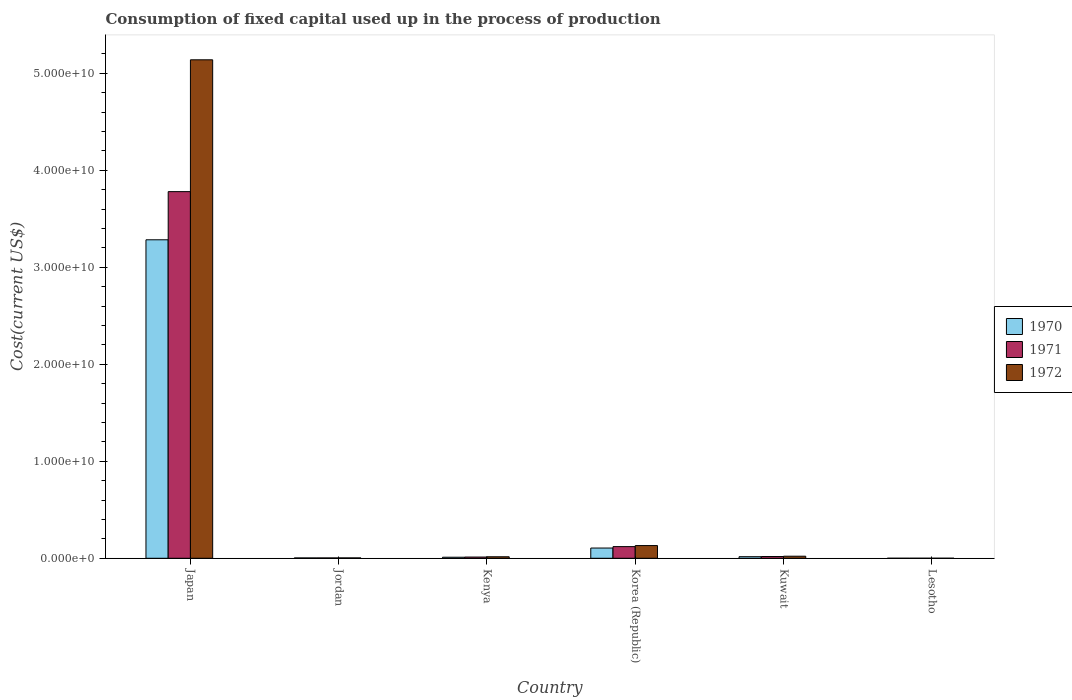How many different coloured bars are there?
Offer a very short reply. 3. Are the number of bars per tick equal to the number of legend labels?
Make the answer very short. Yes. In how many cases, is the number of bars for a given country not equal to the number of legend labels?
Your answer should be compact. 0. What is the amount consumed in the process of production in 1970 in Lesotho?
Ensure brevity in your answer.  1.88e+06. Across all countries, what is the maximum amount consumed in the process of production in 1972?
Offer a terse response. 5.14e+1. Across all countries, what is the minimum amount consumed in the process of production in 1970?
Provide a succinct answer. 1.88e+06. In which country was the amount consumed in the process of production in 1971 minimum?
Provide a succinct answer. Lesotho. What is the total amount consumed in the process of production in 1971 in the graph?
Offer a terse response. 3.93e+1. What is the difference between the amount consumed in the process of production in 1972 in Jordan and that in Lesotho?
Ensure brevity in your answer.  3.64e+07. What is the difference between the amount consumed in the process of production in 1971 in Kenya and the amount consumed in the process of production in 1970 in Japan?
Your answer should be compact. -3.27e+1. What is the average amount consumed in the process of production in 1971 per country?
Keep it short and to the point. 6.56e+09. What is the difference between the amount consumed in the process of production of/in 1972 and amount consumed in the process of production of/in 1970 in Korea (Republic)?
Provide a short and direct response. 2.55e+08. What is the ratio of the amount consumed in the process of production in 1972 in Kenya to that in Lesotho?
Offer a terse response. 70.16. Is the difference between the amount consumed in the process of production in 1972 in Jordan and Lesotho greater than the difference between the amount consumed in the process of production in 1970 in Jordan and Lesotho?
Your response must be concise. Yes. What is the difference between the highest and the second highest amount consumed in the process of production in 1970?
Give a very brief answer. -3.18e+1. What is the difference between the highest and the lowest amount consumed in the process of production in 1970?
Offer a very short reply. 3.28e+1. In how many countries, is the amount consumed in the process of production in 1971 greater than the average amount consumed in the process of production in 1971 taken over all countries?
Your response must be concise. 1. What does the 3rd bar from the left in Kuwait represents?
Offer a very short reply. 1972. Is it the case that in every country, the sum of the amount consumed in the process of production in 1972 and amount consumed in the process of production in 1971 is greater than the amount consumed in the process of production in 1970?
Make the answer very short. Yes. How many bars are there?
Your answer should be very brief. 18. Are all the bars in the graph horizontal?
Offer a very short reply. No. What is the difference between two consecutive major ticks on the Y-axis?
Offer a terse response. 1.00e+1. Does the graph contain any zero values?
Provide a succinct answer. No. Does the graph contain grids?
Give a very brief answer. No. How many legend labels are there?
Your answer should be very brief. 3. What is the title of the graph?
Your answer should be compact. Consumption of fixed capital used up in the process of production. Does "2001" appear as one of the legend labels in the graph?
Keep it short and to the point. No. What is the label or title of the X-axis?
Provide a succinct answer. Country. What is the label or title of the Y-axis?
Offer a terse response. Cost(current US$). What is the Cost(current US$) of 1970 in Japan?
Provide a short and direct response. 3.28e+1. What is the Cost(current US$) in 1971 in Japan?
Offer a terse response. 3.78e+1. What is the Cost(current US$) of 1972 in Japan?
Provide a short and direct response. 5.14e+1. What is the Cost(current US$) of 1970 in Jordan?
Offer a terse response. 3.46e+07. What is the Cost(current US$) of 1971 in Jordan?
Make the answer very short. 3.55e+07. What is the Cost(current US$) in 1972 in Jordan?
Offer a terse response. 3.86e+07. What is the Cost(current US$) of 1970 in Kenya?
Make the answer very short. 1.08e+08. What is the Cost(current US$) in 1971 in Kenya?
Give a very brief answer. 1.25e+08. What is the Cost(current US$) of 1972 in Kenya?
Offer a very short reply. 1.55e+08. What is the Cost(current US$) of 1970 in Korea (Republic)?
Keep it short and to the point. 1.05e+09. What is the Cost(current US$) of 1971 in Korea (Republic)?
Give a very brief answer. 1.20e+09. What is the Cost(current US$) of 1972 in Korea (Republic)?
Offer a terse response. 1.31e+09. What is the Cost(current US$) of 1970 in Kuwait?
Keep it short and to the point. 1.62e+08. What is the Cost(current US$) in 1971 in Kuwait?
Your answer should be compact. 1.80e+08. What is the Cost(current US$) of 1972 in Kuwait?
Offer a terse response. 2.13e+08. What is the Cost(current US$) of 1970 in Lesotho?
Provide a succinct answer. 1.88e+06. What is the Cost(current US$) of 1971 in Lesotho?
Ensure brevity in your answer.  2.43e+06. What is the Cost(current US$) in 1972 in Lesotho?
Ensure brevity in your answer.  2.21e+06. Across all countries, what is the maximum Cost(current US$) in 1970?
Your answer should be compact. 3.28e+1. Across all countries, what is the maximum Cost(current US$) in 1971?
Ensure brevity in your answer.  3.78e+1. Across all countries, what is the maximum Cost(current US$) in 1972?
Your response must be concise. 5.14e+1. Across all countries, what is the minimum Cost(current US$) in 1970?
Your answer should be very brief. 1.88e+06. Across all countries, what is the minimum Cost(current US$) in 1971?
Your response must be concise. 2.43e+06. Across all countries, what is the minimum Cost(current US$) of 1972?
Your response must be concise. 2.21e+06. What is the total Cost(current US$) of 1970 in the graph?
Make the answer very short. 3.42e+1. What is the total Cost(current US$) in 1971 in the graph?
Offer a very short reply. 3.93e+1. What is the total Cost(current US$) of 1972 in the graph?
Offer a very short reply. 5.31e+1. What is the difference between the Cost(current US$) of 1970 in Japan and that in Jordan?
Your answer should be very brief. 3.28e+1. What is the difference between the Cost(current US$) in 1971 in Japan and that in Jordan?
Offer a terse response. 3.78e+1. What is the difference between the Cost(current US$) in 1972 in Japan and that in Jordan?
Provide a short and direct response. 5.14e+1. What is the difference between the Cost(current US$) in 1970 in Japan and that in Kenya?
Ensure brevity in your answer.  3.27e+1. What is the difference between the Cost(current US$) in 1971 in Japan and that in Kenya?
Give a very brief answer. 3.77e+1. What is the difference between the Cost(current US$) in 1972 in Japan and that in Kenya?
Keep it short and to the point. 5.12e+1. What is the difference between the Cost(current US$) of 1970 in Japan and that in Korea (Republic)?
Keep it short and to the point. 3.18e+1. What is the difference between the Cost(current US$) of 1971 in Japan and that in Korea (Republic)?
Keep it short and to the point. 3.66e+1. What is the difference between the Cost(current US$) of 1972 in Japan and that in Korea (Republic)?
Give a very brief answer. 5.01e+1. What is the difference between the Cost(current US$) of 1970 in Japan and that in Kuwait?
Offer a very short reply. 3.27e+1. What is the difference between the Cost(current US$) in 1971 in Japan and that in Kuwait?
Your answer should be compact. 3.76e+1. What is the difference between the Cost(current US$) of 1972 in Japan and that in Kuwait?
Make the answer very short. 5.12e+1. What is the difference between the Cost(current US$) in 1970 in Japan and that in Lesotho?
Your answer should be very brief. 3.28e+1. What is the difference between the Cost(current US$) in 1971 in Japan and that in Lesotho?
Make the answer very short. 3.78e+1. What is the difference between the Cost(current US$) in 1972 in Japan and that in Lesotho?
Provide a succinct answer. 5.14e+1. What is the difference between the Cost(current US$) of 1970 in Jordan and that in Kenya?
Ensure brevity in your answer.  -7.34e+07. What is the difference between the Cost(current US$) of 1971 in Jordan and that in Kenya?
Make the answer very short. -9.00e+07. What is the difference between the Cost(current US$) in 1972 in Jordan and that in Kenya?
Make the answer very short. -1.16e+08. What is the difference between the Cost(current US$) in 1970 in Jordan and that in Korea (Republic)?
Your answer should be compact. -1.02e+09. What is the difference between the Cost(current US$) of 1971 in Jordan and that in Korea (Republic)?
Your response must be concise. -1.17e+09. What is the difference between the Cost(current US$) in 1972 in Jordan and that in Korea (Republic)?
Ensure brevity in your answer.  -1.27e+09. What is the difference between the Cost(current US$) of 1970 in Jordan and that in Kuwait?
Offer a very short reply. -1.28e+08. What is the difference between the Cost(current US$) in 1971 in Jordan and that in Kuwait?
Keep it short and to the point. -1.44e+08. What is the difference between the Cost(current US$) in 1972 in Jordan and that in Kuwait?
Ensure brevity in your answer.  -1.74e+08. What is the difference between the Cost(current US$) in 1970 in Jordan and that in Lesotho?
Make the answer very short. 3.27e+07. What is the difference between the Cost(current US$) in 1971 in Jordan and that in Lesotho?
Offer a very short reply. 3.31e+07. What is the difference between the Cost(current US$) in 1972 in Jordan and that in Lesotho?
Give a very brief answer. 3.64e+07. What is the difference between the Cost(current US$) in 1970 in Kenya and that in Korea (Republic)?
Ensure brevity in your answer.  -9.46e+08. What is the difference between the Cost(current US$) of 1971 in Kenya and that in Korea (Republic)?
Offer a terse response. -1.08e+09. What is the difference between the Cost(current US$) of 1972 in Kenya and that in Korea (Republic)?
Provide a succinct answer. -1.15e+09. What is the difference between the Cost(current US$) in 1970 in Kenya and that in Kuwait?
Your answer should be very brief. -5.44e+07. What is the difference between the Cost(current US$) of 1971 in Kenya and that in Kuwait?
Make the answer very short. -5.42e+07. What is the difference between the Cost(current US$) in 1972 in Kenya and that in Kuwait?
Your response must be concise. -5.82e+07. What is the difference between the Cost(current US$) of 1970 in Kenya and that in Lesotho?
Your answer should be very brief. 1.06e+08. What is the difference between the Cost(current US$) of 1971 in Kenya and that in Lesotho?
Ensure brevity in your answer.  1.23e+08. What is the difference between the Cost(current US$) in 1972 in Kenya and that in Lesotho?
Make the answer very short. 1.53e+08. What is the difference between the Cost(current US$) in 1970 in Korea (Republic) and that in Kuwait?
Provide a short and direct response. 8.92e+08. What is the difference between the Cost(current US$) of 1971 in Korea (Republic) and that in Kuwait?
Make the answer very short. 1.02e+09. What is the difference between the Cost(current US$) in 1972 in Korea (Republic) and that in Kuwait?
Your answer should be very brief. 1.10e+09. What is the difference between the Cost(current US$) of 1970 in Korea (Republic) and that in Lesotho?
Give a very brief answer. 1.05e+09. What is the difference between the Cost(current US$) of 1971 in Korea (Republic) and that in Lesotho?
Your answer should be compact. 1.20e+09. What is the difference between the Cost(current US$) of 1972 in Korea (Republic) and that in Lesotho?
Your answer should be compact. 1.31e+09. What is the difference between the Cost(current US$) in 1970 in Kuwait and that in Lesotho?
Provide a short and direct response. 1.61e+08. What is the difference between the Cost(current US$) in 1971 in Kuwait and that in Lesotho?
Make the answer very short. 1.77e+08. What is the difference between the Cost(current US$) of 1972 in Kuwait and that in Lesotho?
Offer a terse response. 2.11e+08. What is the difference between the Cost(current US$) in 1970 in Japan and the Cost(current US$) in 1971 in Jordan?
Ensure brevity in your answer.  3.28e+1. What is the difference between the Cost(current US$) of 1970 in Japan and the Cost(current US$) of 1972 in Jordan?
Give a very brief answer. 3.28e+1. What is the difference between the Cost(current US$) in 1971 in Japan and the Cost(current US$) in 1972 in Jordan?
Offer a very short reply. 3.78e+1. What is the difference between the Cost(current US$) in 1970 in Japan and the Cost(current US$) in 1971 in Kenya?
Your response must be concise. 3.27e+1. What is the difference between the Cost(current US$) in 1970 in Japan and the Cost(current US$) in 1972 in Kenya?
Make the answer very short. 3.27e+1. What is the difference between the Cost(current US$) in 1971 in Japan and the Cost(current US$) in 1972 in Kenya?
Your answer should be very brief. 3.76e+1. What is the difference between the Cost(current US$) of 1970 in Japan and the Cost(current US$) of 1971 in Korea (Republic)?
Offer a very short reply. 3.16e+1. What is the difference between the Cost(current US$) in 1970 in Japan and the Cost(current US$) in 1972 in Korea (Republic)?
Ensure brevity in your answer.  3.15e+1. What is the difference between the Cost(current US$) of 1971 in Japan and the Cost(current US$) of 1972 in Korea (Republic)?
Offer a terse response. 3.65e+1. What is the difference between the Cost(current US$) in 1970 in Japan and the Cost(current US$) in 1971 in Kuwait?
Ensure brevity in your answer.  3.27e+1. What is the difference between the Cost(current US$) of 1970 in Japan and the Cost(current US$) of 1972 in Kuwait?
Offer a very short reply. 3.26e+1. What is the difference between the Cost(current US$) of 1971 in Japan and the Cost(current US$) of 1972 in Kuwait?
Your answer should be very brief. 3.76e+1. What is the difference between the Cost(current US$) of 1970 in Japan and the Cost(current US$) of 1971 in Lesotho?
Give a very brief answer. 3.28e+1. What is the difference between the Cost(current US$) in 1970 in Japan and the Cost(current US$) in 1972 in Lesotho?
Your answer should be compact. 3.28e+1. What is the difference between the Cost(current US$) in 1971 in Japan and the Cost(current US$) in 1972 in Lesotho?
Offer a very short reply. 3.78e+1. What is the difference between the Cost(current US$) of 1970 in Jordan and the Cost(current US$) of 1971 in Kenya?
Provide a short and direct response. -9.09e+07. What is the difference between the Cost(current US$) of 1970 in Jordan and the Cost(current US$) of 1972 in Kenya?
Your answer should be compact. -1.20e+08. What is the difference between the Cost(current US$) in 1971 in Jordan and the Cost(current US$) in 1972 in Kenya?
Offer a very short reply. -1.19e+08. What is the difference between the Cost(current US$) in 1970 in Jordan and the Cost(current US$) in 1971 in Korea (Republic)?
Your response must be concise. -1.17e+09. What is the difference between the Cost(current US$) in 1970 in Jordan and the Cost(current US$) in 1972 in Korea (Republic)?
Offer a terse response. -1.27e+09. What is the difference between the Cost(current US$) in 1971 in Jordan and the Cost(current US$) in 1972 in Korea (Republic)?
Keep it short and to the point. -1.27e+09. What is the difference between the Cost(current US$) of 1970 in Jordan and the Cost(current US$) of 1971 in Kuwait?
Your answer should be very brief. -1.45e+08. What is the difference between the Cost(current US$) in 1970 in Jordan and the Cost(current US$) in 1972 in Kuwait?
Make the answer very short. -1.78e+08. What is the difference between the Cost(current US$) of 1971 in Jordan and the Cost(current US$) of 1972 in Kuwait?
Ensure brevity in your answer.  -1.77e+08. What is the difference between the Cost(current US$) of 1970 in Jordan and the Cost(current US$) of 1971 in Lesotho?
Offer a terse response. 3.22e+07. What is the difference between the Cost(current US$) of 1970 in Jordan and the Cost(current US$) of 1972 in Lesotho?
Ensure brevity in your answer.  3.24e+07. What is the difference between the Cost(current US$) in 1971 in Jordan and the Cost(current US$) in 1972 in Lesotho?
Your answer should be compact. 3.33e+07. What is the difference between the Cost(current US$) of 1970 in Kenya and the Cost(current US$) of 1971 in Korea (Republic)?
Provide a succinct answer. -1.09e+09. What is the difference between the Cost(current US$) of 1970 in Kenya and the Cost(current US$) of 1972 in Korea (Republic)?
Give a very brief answer. -1.20e+09. What is the difference between the Cost(current US$) in 1971 in Kenya and the Cost(current US$) in 1972 in Korea (Republic)?
Give a very brief answer. -1.18e+09. What is the difference between the Cost(current US$) of 1970 in Kenya and the Cost(current US$) of 1971 in Kuwait?
Give a very brief answer. -7.17e+07. What is the difference between the Cost(current US$) in 1970 in Kenya and the Cost(current US$) in 1972 in Kuwait?
Your answer should be compact. -1.05e+08. What is the difference between the Cost(current US$) in 1971 in Kenya and the Cost(current US$) in 1972 in Kuwait?
Offer a very short reply. -8.75e+07. What is the difference between the Cost(current US$) of 1970 in Kenya and the Cost(current US$) of 1971 in Lesotho?
Offer a very short reply. 1.06e+08. What is the difference between the Cost(current US$) of 1970 in Kenya and the Cost(current US$) of 1972 in Lesotho?
Provide a succinct answer. 1.06e+08. What is the difference between the Cost(current US$) of 1971 in Kenya and the Cost(current US$) of 1972 in Lesotho?
Make the answer very short. 1.23e+08. What is the difference between the Cost(current US$) of 1970 in Korea (Republic) and the Cost(current US$) of 1971 in Kuwait?
Your answer should be compact. 8.74e+08. What is the difference between the Cost(current US$) in 1970 in Korea (Republic) and the Cost(current US$) in 1972 in Kuwait?
Your answer should be very brief. 8.41e+08. What is the difference between the Cost(current US$) in 1971 in Korea (Republic) and the Cost(current US$) in 1972 in Kuwait?
Keep it short and to the point. 9.89e+08. What is the difference between the Cost(current US$) of 1970 in Korea (Republic) and the Cost(current US$) of 1971 in Lesotho?
Make the answer very short. 1.05e+09. What is the difference between the Cost(current US$) in 1970 in Korea (Republic) and the Cost(current US$) in 1972 in Lesotho?
Keep it short and to the point. 1.05e+09. What is the difference between the Cost(current US$) in 1971 in Korea (Republic) and the Cost(current US$) in 1972 in Lesotho?
Keep it short and to the point. 1.20e+09. What is the difference between the Cost(current US$) of 1970 in Kuwait and the Cost(current US$) of 1971 in Lesotho?
Your response must be concise. 1.60e+08. What is the difference between the Cost(current US$) of 1970 in Kuwait and the Cost(current US$) of 1972 in Lesotho?
Provide a succinct answer. 1.60e+08. What is the difference between the Cost(current US$) in 1971 in Kuwait and the Cost(current US$) in 1972 in Lesotho?
Keep it short and to the point. 1.77e+08. What is the average Cost(current US$) of 1970 per country?
Your response must be concise. 5.70e+09. What is the average Cost(current US$) in 1971 per country?
Your answer should be very brief. 6.56e+09. What is the average Cost(current US$) of 1972 per country?
Give a very brief answer. 8.85e+09. What is the difference between the Cost(current US$) in 1970 and Cost(current US$) in 1971 in Japan?
Make the answer very short. -4.97e+09. What is the difference between the Cost(current US$) in 1970 and Cost(current US$) in 1972 in Japan?
Provide a succinct answer. -1.86e+1. What is the difference between the Cost(current US$) of 1971 and Cost(current US$) of 1972 in Japan?
Provide a succinct answer. -1.36e+1. What is the difference between the Cost(current US$) of 1970 and Cost(current US$) of 1971 in Jordan?
Offer a terse response. -9.20e+05. What is the difference between the Cost(current US$) of 1970 and Cost(current US$) of 1972 in Jordan?
Your response must be concise. -4.07e+06. What is the difference between the Cost(current US$) in 1971 and Cost(current US$) in 1972 in Jordan?
Offer a very short reply. -3.15e+06. What is the difference between the Cost(current US$) of 1970 and Cost(current US$) of 1971 in Kenya?
Keep it short and to the point. -1.75e+07. What is the difference between the Cost(current US$) in 1970 and Cost(current US$) in 1972 in Kenya?
Provide a short and direct response. -4.68e+07. What is the difference between the Cost(current US$) in 1971 and Cost(current US$) in 1972 in Kenya?
Provide a short and direct response. -2.93e+07. What is the difference between the Cost(current US$) of 1970 and Cost(current US$) of 1971 in Korea (Republic)?
Make the answer very short. -1.48e+08. What is the difference between the Cost(current US$) in 1970 and Cost(current US$) in 1972 in Korea (Republic)?
Your answer should be compact. -2.55e+08. What is the difference between the Cost(current US$) in 1971 and Cost(current US$) in 1972 in Korea (Republic)?
Your response must be concise. -1.08e+08. What is the difference between the Cost(current US$) in 1970 and Cost(current US$) in 1971 in Kuwait?
Keep it short and to the point. -1.73e+07. What is the difference between the Cost(current US$) in 1970 and Cost(current US$) in 1972 in Kuwait?
Make the answer very short. -5.05e+07. What is the difference between the Cost(current US$) in 1971 and Cost(current US$) in 1972 in Kuwait?
Your answer should be compact. -3.32e+07. What is the difference between the Cost(current US$) of 1970 and Cost(current US$) of 1971 in Lesotho?
Provide a short and direct response. -5.49e+05. What is the difference between the Cost(current US$) in 1970 and Cost(current US$) in 1972 in Lesotho?
Keep it short and to the point. -3.25e+05. What is the difference between the Cost(current US$) of 1971 and Cost(current US$) of 1972 in Lesotho?
Offer a very short reply. 2.24e+05. What is the ratio of the Cost(current US$) in 1970 in Japan to that in Jordan?
Provide a succinct answer. 949.54. What is the ratio of the Cost(current US$) of 1971 in Japan to that in Jordan?
Make the answer very short. 1064.79. What is the ratio of the Cost(current US$) in 1972 in Japan to that in Jordan?
Your answer should be compact. 1329.83. What is the ratio of the Cost(current US$) of 1970 in Japan to that in Kenya?
Make the answer very short. 304.02. What is the ratio of the Cost(current US$) of 1971 in Japan to that in Kenya?
Keep it short and to the point. 301.26. What is the ratio of the Cost(current US$) in 1972 in Japan to that in Kenya?
Your answer should be compact. 332.03. What is the ratio of the Cost(current US$) in 1970 in Japan to that in Korea (Republic)?
Offer a very short reply. 31.15. What is the ratio of the Cost(current US$) in 1971 in Japan to that in Korea (Republic)?
Offer a terse response. 31.45. What is the ratio of the Cost(current US$) of 1972 in Japan to that in Korea (Republic)?
Ensure brevity in your answer.  39.25. What is the ratio of the Cost(current US$) of 1970 in Japan to that in Kuwait?
Your response must be concise. 202.13. What is the ratio of the Cost(current US$) of 1971 in Japan to that in Kuwait?
Give a very brief answer. 210.36. What is the ratio of the Cost(current US$) in 1972 in Japan to that in Kuwait?
Offer a terse response. 241.35. What is the ratio of the Cost(current US$) in 1970 in Japan to that in Lesotho?
Your answer should be very brief. 1.75e+04. What is the ratio of the Cost(current US$) in 1971 in Japan to that in Lesotho?
Provide a short and direct response. 1.56e+04. What is the ratio of the Cost(current US$) of 1972 in Japan to that in Lesotho?
Ensure brevity in your answer.  2.33e+04. What is the ratio of the Cost(current US$) of 1970 in Jordan to that in Kenya?
Keep it short and to the point. 0.32. What is the ratio of the Cost(current US$) of 1971 in Jordan to that in Kenya?
Give a very brief answer. 0.28. What is the ratio of the Cost(current US$) of 1972 in Jordan to that in Kenya?
Offer a terse response. 0.25. What is the ratio of the Cost(current US$) of 1970 in Jordan to that in Korea (Republic)?
Provide a succinct answer. 0.03. What is the ratio of the Cost(current US$) of 1971 in Jordan to that in Korea (Republic)?
Your answer should be very brief. 0.03. What is the ratio of the Cost(current US$) in 1972 in Jordan to that in Korea (Republic)?
Keep it short and to the point. 0.03. What is the ratio of the Cost(current US$) of 1970 in Jordan to that in Kuwait?
Your response must be concise. 0.21. What is the ratio of the Cost(current US$) in 1971 in Jordan to that in Kuwait?
Ensure brevity in your answer.  0.2. What is the ratio of the Cost(current US$) in 1972 in Jordan to that in Kuwait?
Your answer should be very brief. 0.18. What is the ratio of the Cost(current US$) of 1970 in Jordan to that in Lesotho?
Offer a very short reply. 18.39. What is the ratio of the Cost(current US$) in 1971 in Jordan to that in Lesotho?
Offer a terse response. 14.61. What is the ratio of the Cost(current US$) in 1972 in Jordan to that in Lesotho?
Your answer should be compact. 17.52. What is the ratio of the Cost(current US$) of 1970 in Kenya to that in Korea (Republic)?
Provide a short and direct response. 0.1. What is the ratio of the Cost(current US$) in 1971 in Kenya to that in Korea (Republic)?
Offer a very short reply. 0.1. What is the ratio of the Cost(current US$) in 1972 in Kenya to that in Korea (Republic)?
Make the answer very short. 0.12. What is the ratio of the Cost(current US$) in 1970 in Kenya to that in Kuwait?
Ensure brevity in your answer.  0.66. What is the ratio of the Cost(current US$) in 1971 in Kenya to that in Kuwait?
Your answer should be very brief. 0.7. What is the ratio of the Cost(current US$) in 1972 in Kenya to that in Kuwait?
Your answer should be very brief. 0.73. What is the ratio of the Cost(current US$) in 1970 in Kenya to that in Lesotho?
Give a very brief answer. 57.43. What is the ratio of the Cost(current US$) of 1971 in Kenya to that in Lesotho?
Provide a succinct answer. 51.64. What is the ratio of the Cost(current US$) of 1972 in Kenya to that in Lesotho?
Ensure brevity in your answer.  70.16. What is the ratio of the Cost(current US$) in 1970 in Korea (Republic) to that in Kuwait?
Provide a short and direct response. 6.49. What is the ratio of the Cost(current US$) in 1971 in Korea (Republic) to that in Kuwait?
Provide a succinct answer. 6.69. What is the ratio of the Cost(current US$) of 1972 in Korea (Republic) to that in Kuwait?
Make the answer very short. 6.15. What is the ratio of the Cost(current US$) of 1970 in Korea (Republic) to that in Lesotho?
Give a very brief answer. 560.45. What is the ratio of the Cost(current US$) of 1971 in Korea (Republic) to that in Lesotho?
Your response must be concise. 494.59. What is the ratio of the Cost(current US$) of 1972 in Korea (Republic) to that in Lesotho?
Provide a short and direct response. 593.53. What is the ratio of the Cost(current US$) in 1970 in Kuwait to that in Lesotho?
Provide a succinct answer. 86.37. What is the ratio of the Cost(current US$) of 1971 in Kuwait to that in Lesotho?
Your answer should be very brief. 73.95. What is the ratio of the Cost(current US$) of 1972 in Kuwait to that in Lesotho?
Offer a terse response. 96.53. What is the difference between the highest and the second highest Cost(current US$) of 1970?
Your answer should be very brief. 3.18e+1. What is the difference between the highest and the second highest Cost(current US$) in 1971?
Provide a succinct answer. 3.66e+1. What is the difference between the highest and the second highest Cost(current US$) of 1972?
Offer a very short reply. 5.01e+1. What is the difference between the highest and the lowest Cost(current US$) in 1970?
Provide a short and direct response. 3.28e+1. What is the difference between the highest and the lowest Cost(current US$) of 1971?
Your response must be concise. 3.78e+1. What is the difference between the highest and the lowest Cost(current US$) of 1972?
Your answer should be compact. 5.14e+1. 